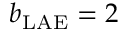Convert formula to latex. <formula><loc_0><loc_0><loc_500><loc_500>b _ { L A E } = 2</formula> 